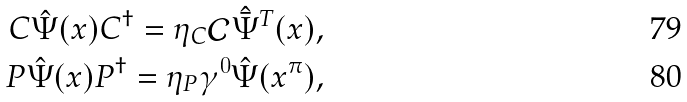Convert formula to latex. <formula><loc_0><loc_0><loc_500><loc_500>C \hat { \Psi } ( x ) C ^ { \dag } = \eta _ { C } \mathcal { C } \hat { \bar { \Psi } } ^ { T } ( x ) , \\ P \hat { \Psi } ( x ) P ^ { \dag } = \eta _ { P } \gamma ^ { 0 } \hat { \Psi } ( x ^ { \pi } ) ,</formula> 